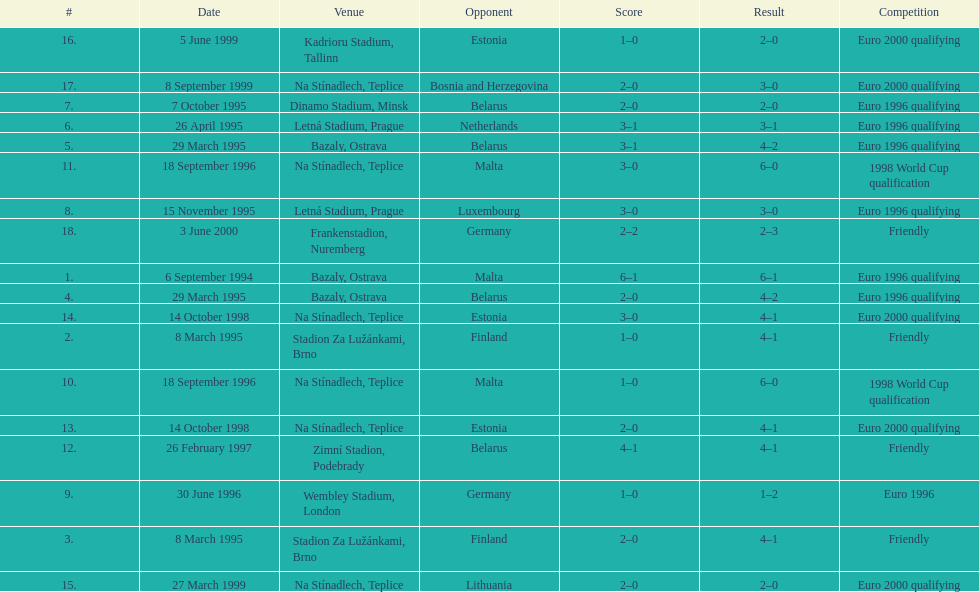Which team did czech republic score the most goals against? Malta. 